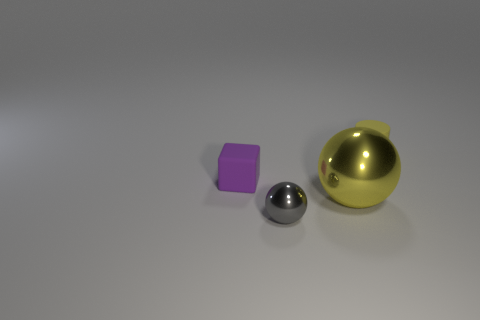Add 4 large purple blocks. How many objects exist? 8 Subtract all cubes. How many objects are left? 3 Add 4 large spheres. How many large spheres exist? 5 Subtract 0 red blocks. How many objects are left? 4 Subtract all rubber things. Subtract all small purple cylinders. How many objects are left? 2 Add 1 tiny blocks. How many tiny blocks are left? 2 